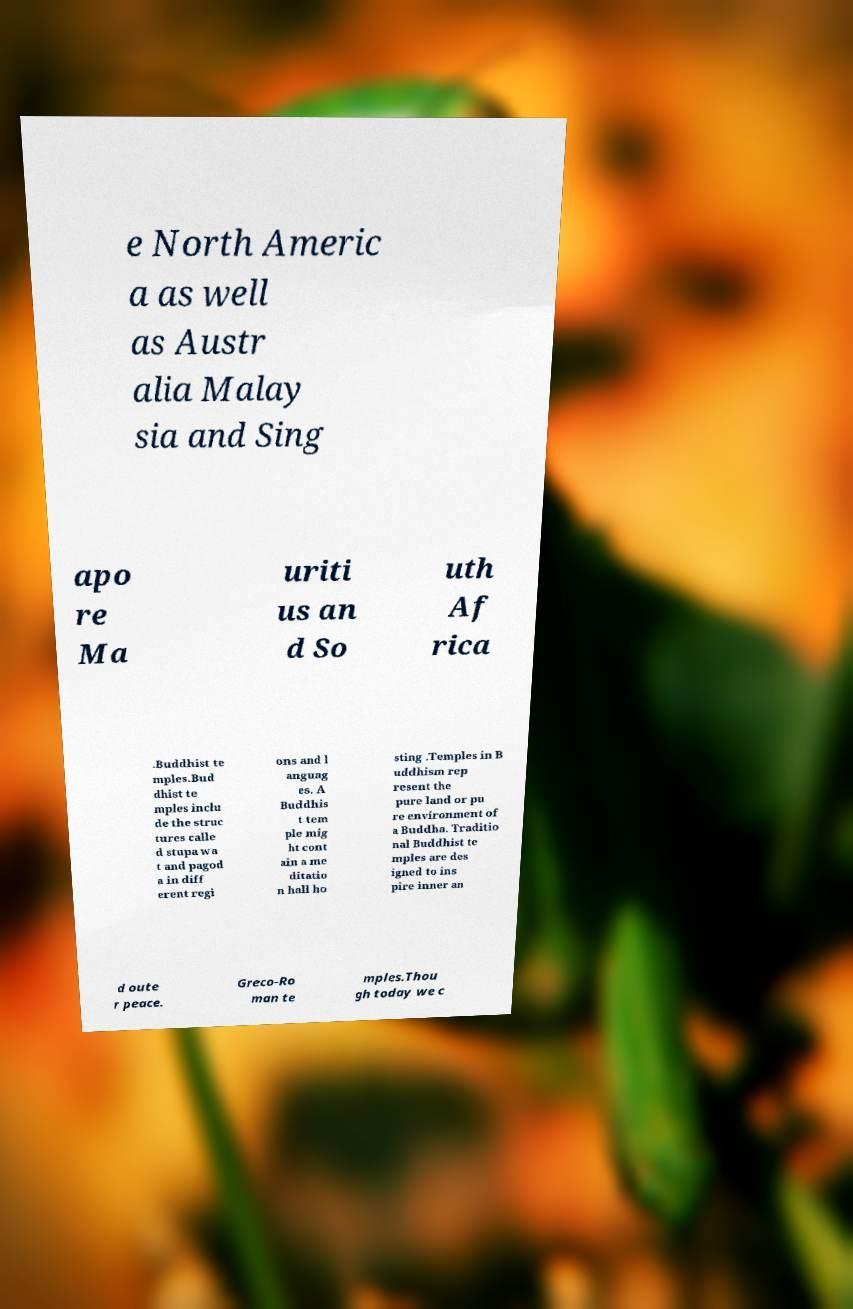Please identify and transcribe the text found in this image. e North Americ a as well as Austr alia Malay sia and Sing apo re Ma uriti us an d So uth Af rica .Buddhist te mples.Bud dhist te mples inclu de the struc tures calle d stupa wa t and pagod a in diff erent regi ons and l anguag es. A Buddhis t tem ple mig ht cont ain a me ditatio n hall ho sting .Temples in B uddhism rep resent the pure land or pu re environment of a Buddha. Traditio nal Buddhist te mples are des igned to ins pire inner an d oute r peace. Greco-Ro man te mples.Thou gh today we c 